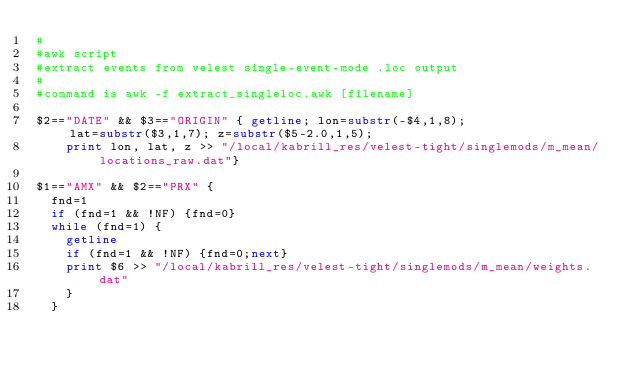<code> <loc_0><loc_0><loc_500><loc_500><_Awk_>#
#awk script
#extract events from velest single-event-mode .loc output
#
#command is awk -f extract_singleloc.awk [filename]

$2=="DATE" && $3=="ORIGIN" { getline; lon=substr(-$4,1,8);                 lat=substr($3,1,7); z=substr($5-2.0,1,5);
    print lon, lat, z >> "/local/kabrill_res/velest-tight/singlemods/m_mean/locations_raw.dat"}

$1=="AMX" && $2=="PRX" { 
	fnd=1
	if (fnd=1 && !NF) {fnd=0}
	while (fnd=1) {
		getline
		if (fnd=1 && !NF) {fnd=0;next}
		print $6 >> "/local/kabrill_res/velest-tight/singlemods/m_mean/weights.dat"
		}
	}
</code> 